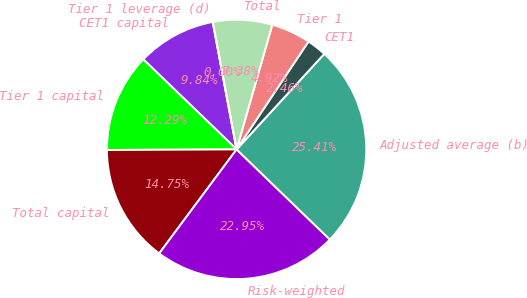Convert chart to OTSL. <chart><loc_0><loc_0><loc_500><loc_500><pie_chart><fcel>CET1 capital<fcel>Tier 1 capital<fcel>Total capital<fcel>Risk-weighted<fcel>Adjusted average (b)<fcel>CET1<fcel>Tier 1<fcel>Total<fcel>Tier 1 leverage (d)<nl><fcel>9.84%<fcel>12.29%<fcel>14.75%<fcel>22.95%<fcel>25.41%<fcel>2.46%<fcel>4.92%<fcel>7.38%<fcel>0.0%<nl></chart> 